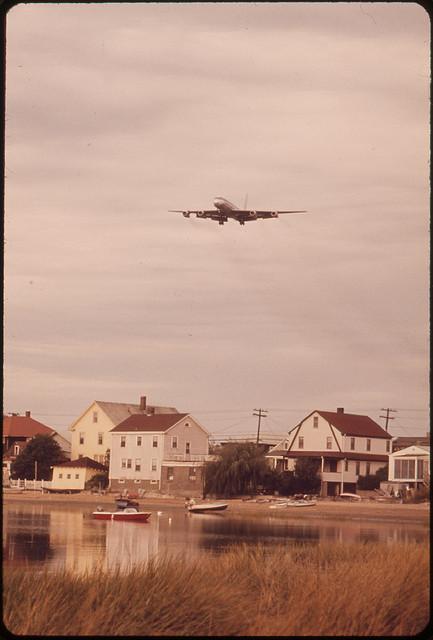Where are the boats?
Write a very short answer. In water. Are there any buildings over five floors tall in this city?
Quick response, please. No. Is it daytime?
Concise answer only. Yes. Do you see a girl?
Give a very brief answer. No. Is the plane flying over water?
Write a very short answer. Yes. What color is the bird?
Answer briefly. White. 